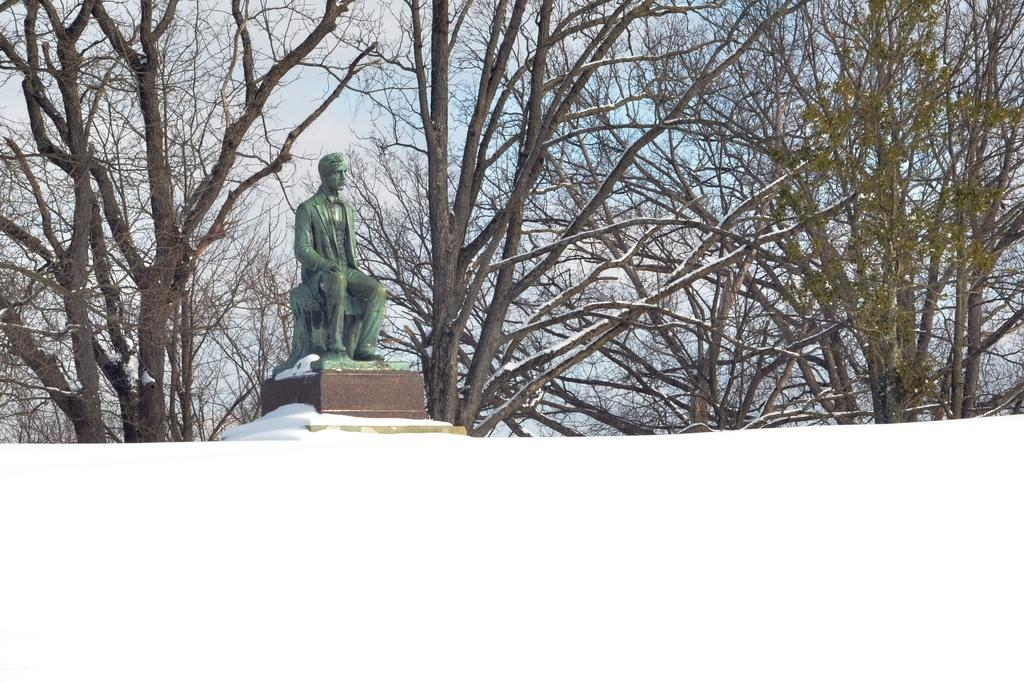What is the main subject in the center of the image? There is a statue in the center of the image. What can be seen in the background of the image? There are trees and the sky visible in the background of the image. How many chickens are present in the image? There are no chickens present in the image. 